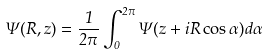<formula> <loc_0><loc_0><loc_500><loc_500>\Psi ( R , z ) = \frac { 1 } { 2 \pi } \int ^ { 2 \pi } _ { 0 } \Psi ( z + i R \cos \alpha ) d \alpha</formula> 